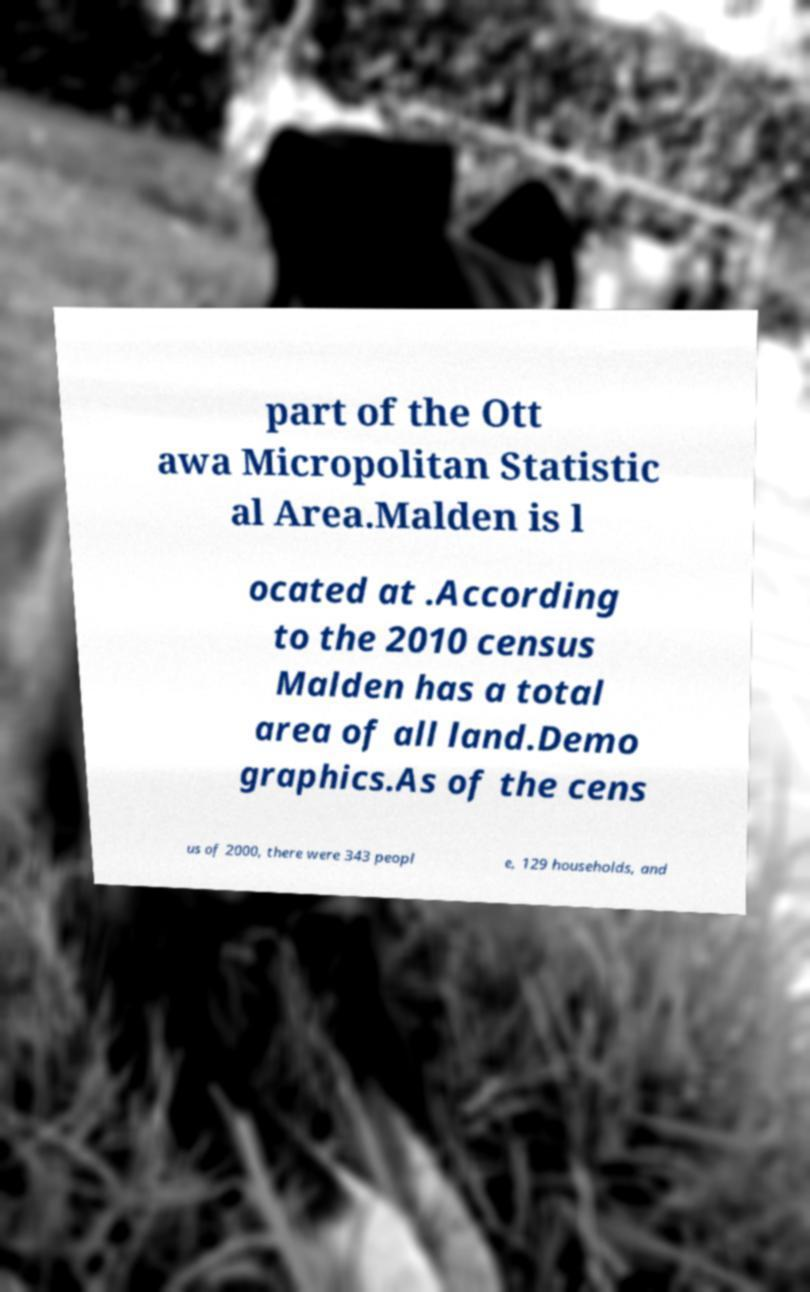Could you extract and type out the text from this image? part of the Ott awa Micropolitan Statistic al Area.Malden is l ocated at .According to the 2010 census Malden has a total area of all land.Demo graphics.As of the cens us of 2000, there were 343 peopl e, 129 households, and 